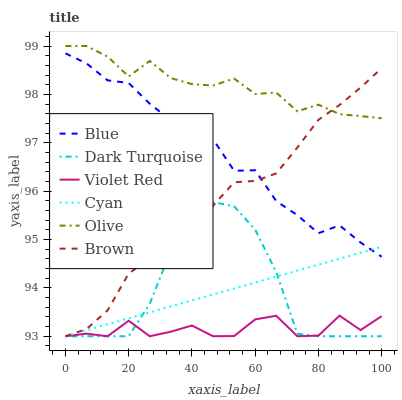Does Violet Red have the minimum area under the curve?
Answer yes or no. Yes. Does Olive have the maximum area under the curve?
Answer yes or no. Yes. Does Brown have the minimum area under the curve?
Answer yes or no. No. Does Brown have the maximum area under the curve?
Answer yes or no. No. Is Cyan the smoothest?
Answer yes or no. Yes. Is Violet Red the roughest?
Answer yes or no. Yes. Is Brown the smoothest?
Answer yes or no. No. Is Brown the roughest?
Answer yes or no. No. Does Brown have the lowest value?
Answer yes or no. Yes. Does Olive have the lowest value?
Answer yes or no. No. Does Olive have the highest value?
Answer yes or no. Yes. Does Brown have the highest value?
Answer yes or no. No. Is Dark Turquoise less than Olive?
Answer yes or no. Yes. Is Blue greater than Dark Turquoise?
Answer yes or no. Yes. Does Violet Red intersect Dark Turquoise?
Answer yes or no. Yes. Is Violet Red less than Dark Turquoise?
Answer yes or no. No. Is Violet Red greater than Dark Turquoise?
Answer yes or no. No. Does Dark Turquoise intersect Olive?
Answer yes or no. No. 